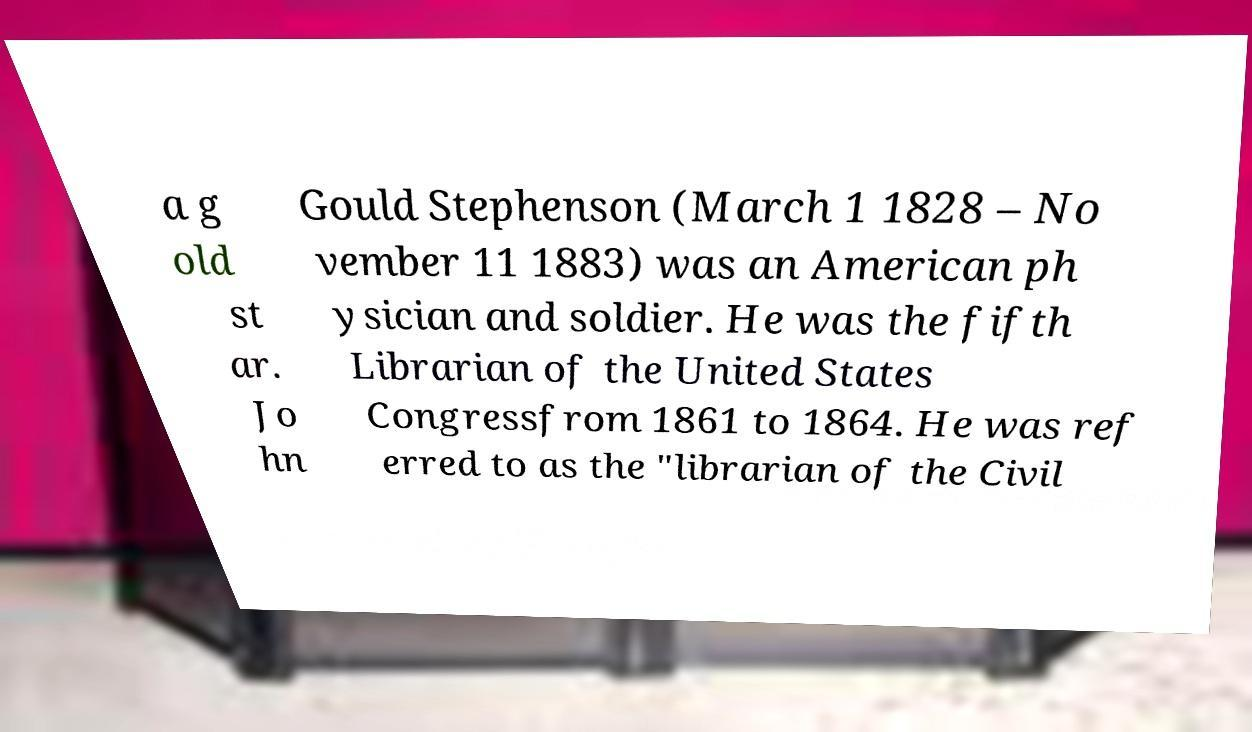What messages or text are displayed in this image? I need them in a readable, typed format. a g old st ar. Jo hn Gould Stephenson (March 1 1828 – No vember 11 1883) was an American ph ysician and soldier. He was the fifth Librarian of the United States Congressfrom 1861 to 1864. He was ref erred to as the "librarian of the Civil 